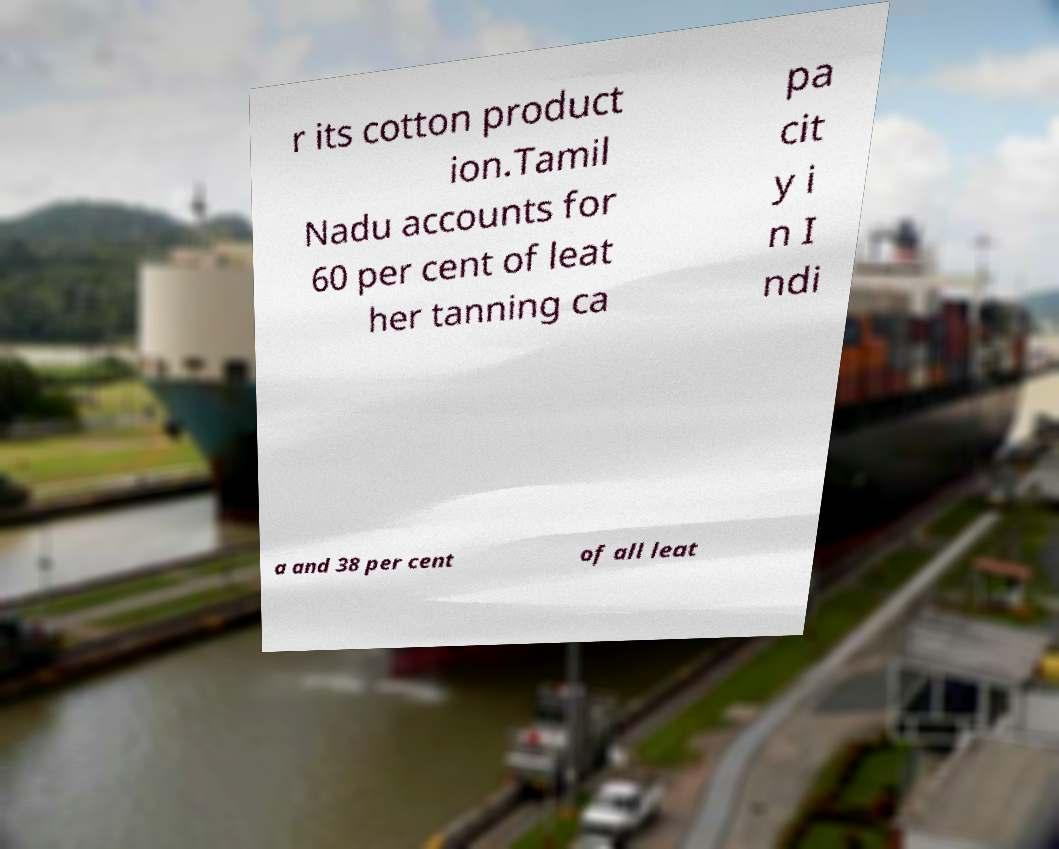I need the written content from this picture converted into text. Can you do that? r its cotton product ion.Tamil Nadu accounts for 60 per cent of leat her tanning ca pa cit y i n I ndi a and 38 per cent of all leat 